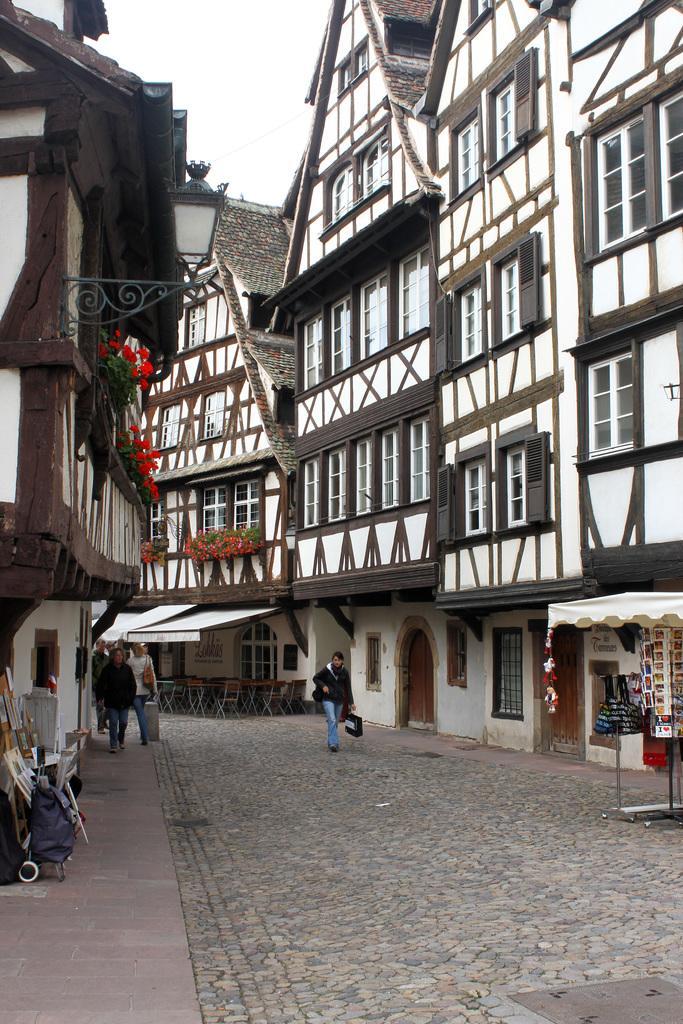Could you give a brief overview of what you see in this image? In this image I can see in the middle a person is walking, this person wore a black color sweater and a blue color trouser. There are buildings on either side of this image and there are flower plants also. At the top there is the sky. 